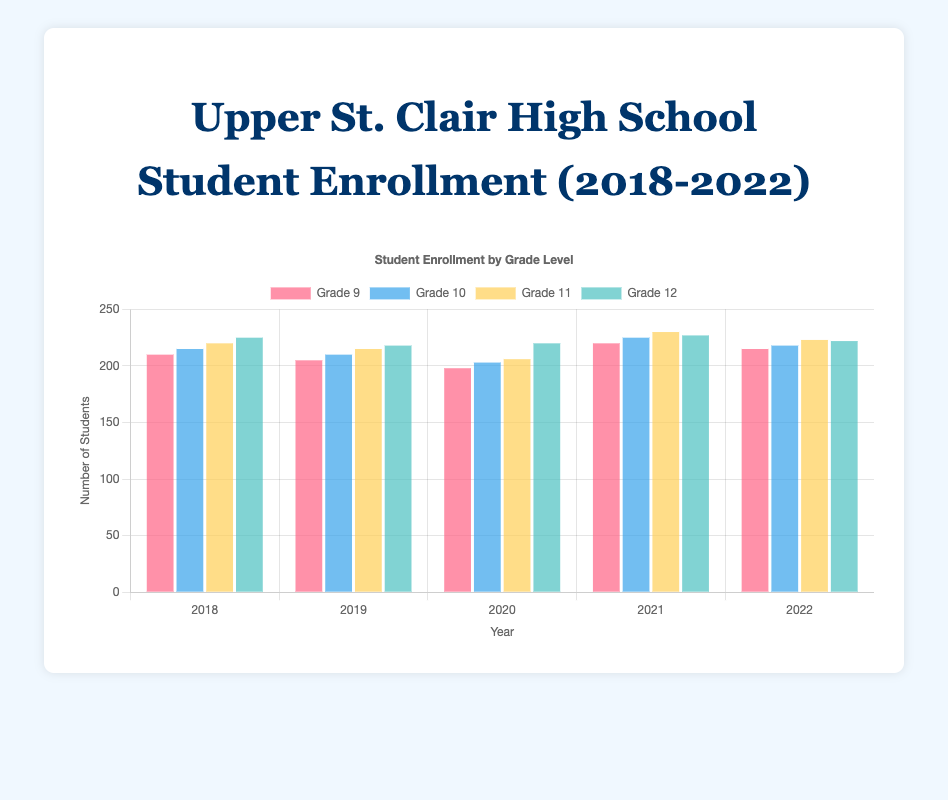Which grade level had the highest enrollment in 2021? The 2021 data shows Grade 11 with 230 students, which is the highest among all grade levels for that year.
Answer: Grade 11 What is the trend in Grade 9 enrollment from 2018 to 2022? Grade 9 enrollment starts at 210 in 2018, slightly decreases to 205 in 2019, further decreases to 198 in 2020, then significantly increases to 220 in 2021, and slightly decreases to 215 in 2022.
Answer: Initially decreases, then increases Compare the enrollment change for Grade 12 from 2018 to 2022. Grade 12 enrollment starts at 225 in 2018, decreases to 218 in 2019, slightly increases to 220 in 2020, peaks at 227 in 2021, and drops to 222 in 2022.
Answer: Slight decrease overall How did Grade 10 enrollment change from 2019 to 2021? The enrollment for Grade 10 in 2019 was 210, then it decreased to 203 in 2020, and increased to 225 in 2021.
Answer: Decreased, then increased Calculate the average enrollment for Grade 11 over the five years. Sum the enrollments for Grade 11: 220 + 215 + 206 + 230 + 223 = 1094, then divide by 5: 1094 / 5 = 218.8
Answer: 218.8 In which year did Grade 10 have its highest enrollment? By comparing each year's Grade 10 data, 2021 had the highest enrollment at 225.
Answer: 2021 What color represents Grade 12 in the chart? The bars for Grade 12 are colored teal.
Answer: Teal 